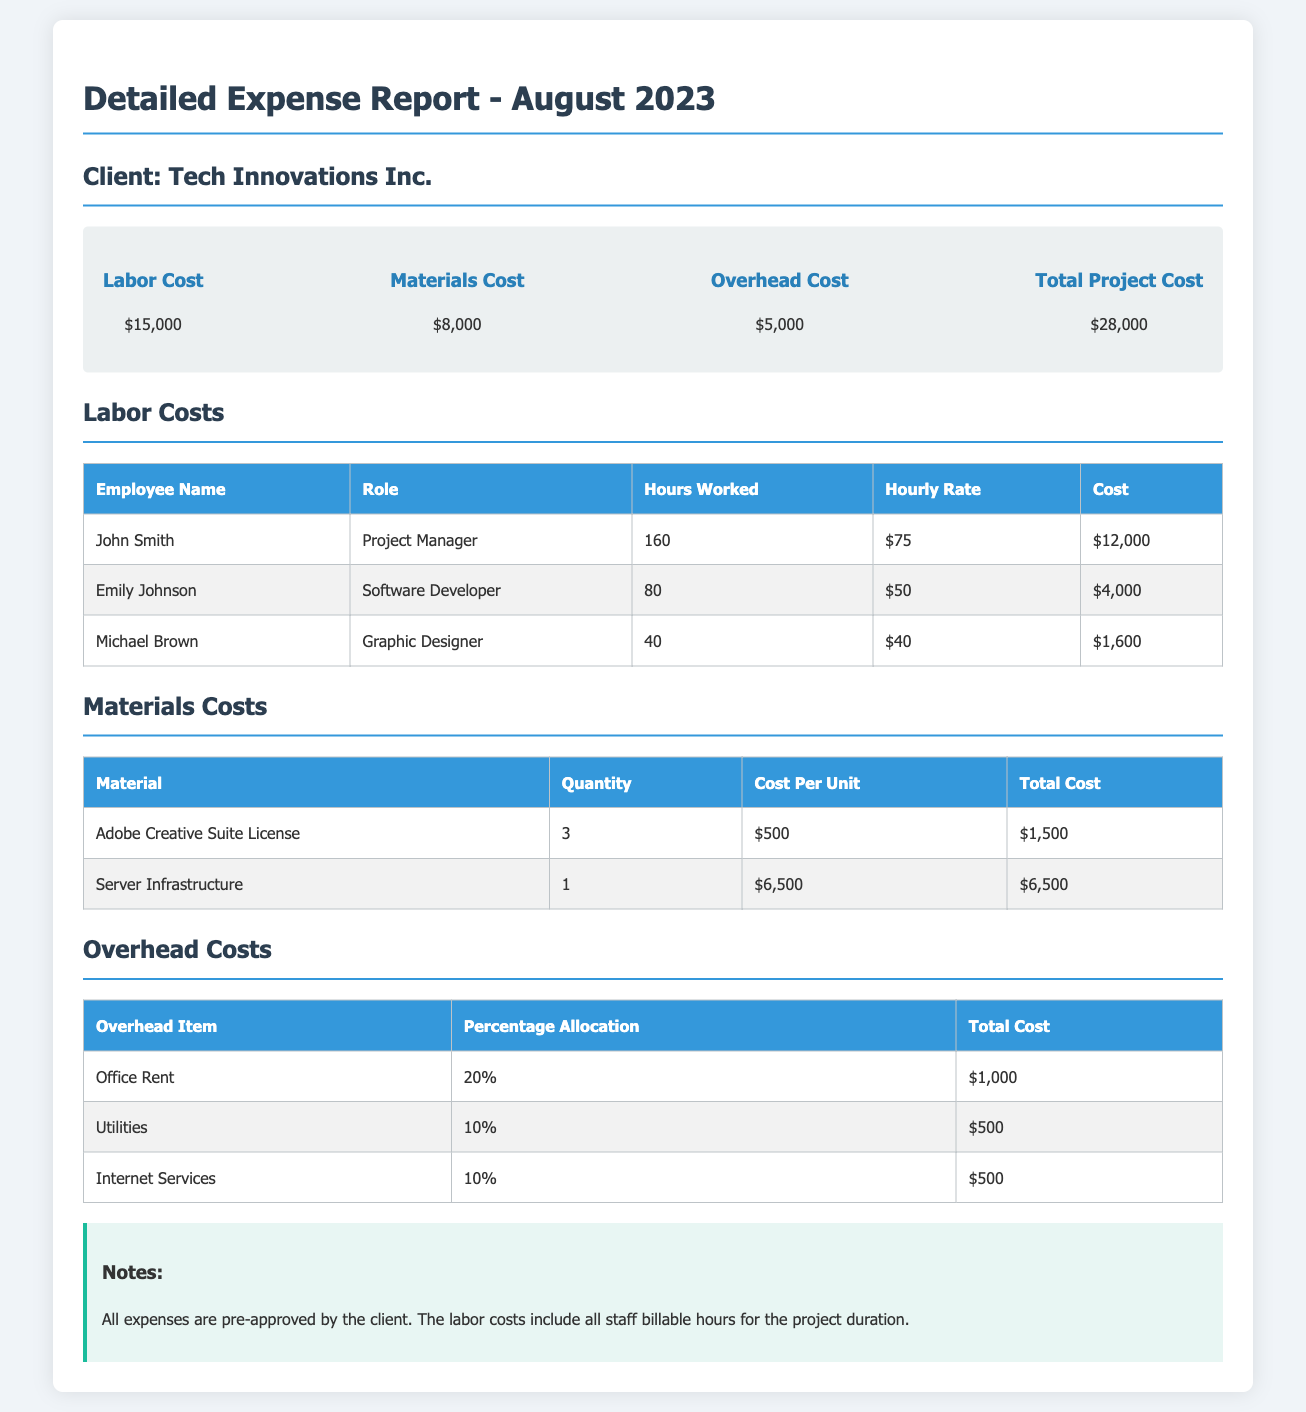What is the total labor cost? The total labor cost is provided in the summary section of the report, which states $15,000.
Answer: $15,000 Who is the Project Manager? The report specifies that the Project Manager is John Smith, listed under labor costs.
Answer: John Smith What is the total cost of materials? The total materials cost is shown in the summary, which indicates $8,000 for materials.
Answer: $8,000 How many hours did Emily Johnson work? The hours worked by Emily Johnson are detailed in the labor costs table, which shows 80 hours.
Answer: 80 What percentage allocation does Office Rent have? The overhead costs section lists Office Rent with a percentage allocation of 20%.
Answer: 20% What is the total project cost? The total project cost is summarized at the end, which amounts to $28,000.
Answer: $28,000 What is the total cost for Internet Services? The overhead costs table specifies Internet Services costing $500.
Answer: $500 How many Adobe Creative Suite Licenses were purchased? The materials costs table indicates that 3 Adobe Creative Suite Licenses were purchased.
Answer: 3 What role does Michael Brown serve? In the labor costs table, Michael Brown is identified as a Graphic Designer.
Answer: Graphic Designer 